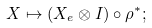<formula> <loc_0><loc_0><loc_500><loc_500>X \mapsto ( X _ { e } \otimes I ) \circ \rho ^ { * } ;</formula> 